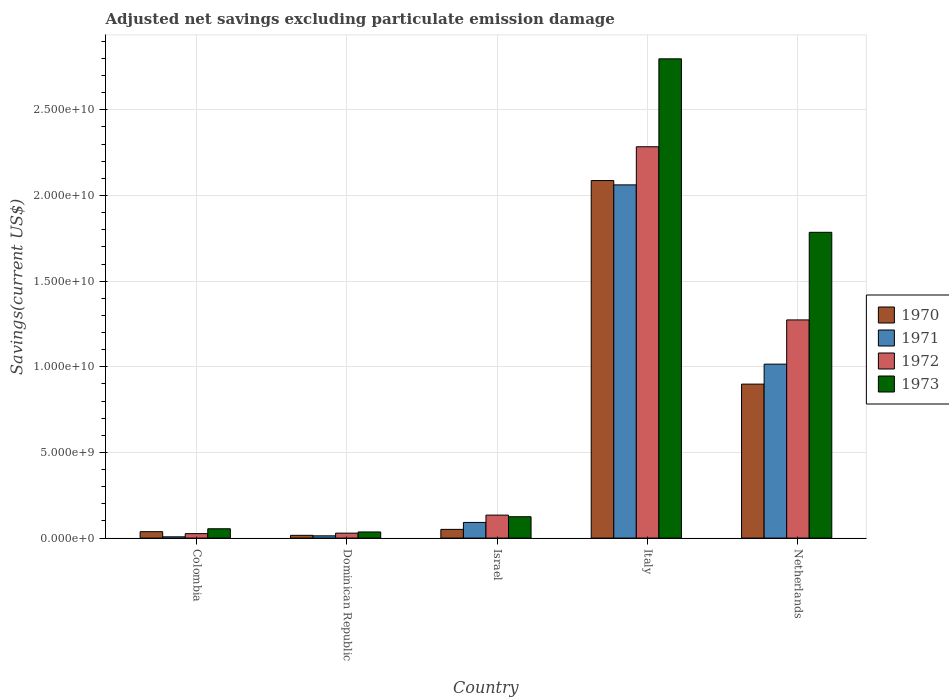Are the number of bars on each tick of the X-axis equal?
Make the answer very short. Yes. How many bars are there on the 1st tick from the left?
Your answer should be very brief. 4. In how many cases, is the number of bars for a given country not equal to the number of legend labels?
Offer a very short reply. 0. What is the adjusted net savings in 1971 in Colombia?
Your response must be concise. 7.46e+07. Across all countries, what is the maximum adjusted net savings in 1972?
Give a very brief answer. 2.28e+1. Across all countries, what is the minimum adjusted net savings in 1971?
Your answer should be very brief. 7.46e+07. In which country was the adjusted net savings in 1973 minimum?
Give a very brief answer. Dominican Republic. What is the total adjusted net savings in 1972 in the graph?
Offer a very short reply. 3.75e+1. What is the difference between the adjusted net savings in 1971 in Colombia and that in Netherlands?
Your response must be concise. -1.01e+1. What is the difference between the adjusted net savings in 1970 in Colombia and the adjusted net savings in 1973 in Netherlands?
Give a very brief answer. -1.75e+1. What is the average adjusted net savings in 1972 per country?
Your response must be concise. 7.49e+09. What is the difference between the adjusted net savings of/in 1972 and adjusted net savings of/in 1971 in Israel?
Offer a terse response. 4.27e+08. What is the ratio of the adjusted net savings in 1973 in Colombia to that in Italy?
Make the answer very short. 0.02. What is the difference between the highest and the second highest adjusted net savings in 1972?
Give a very brief answer. -2.15e+1. What is the difference between the highest and the lowest adjusted net savings in 1972?
Your answer should be compact. 2.26e+1. Is the sum of the adjusted net savings in 1973 in Dominican Republic and Netherlands greater than the maximum adjusted net savings in 1972 across all countries?
Your response must be concise. No. Are all the bars in the graph horizontal?
Keep it short and to the point. No. Are the values on the major ticks of Y-axis written in scientific E-notation?
Your answer should be compact. Yes. Where does the legend appear in the graph?
Keep it short and to the point. Center right. How many legend labels are there?
Give a very brief answer. 4. How are the legend labels stacked?
Your answer should be compact. Vertical. What is the title of the graph?
Offer a very short reply. Adjusted net savings excluding particulate emission damage. Does "1967" appear as one of the legend labels in the graph?
Your response must be concise. No. What is the label or title of the X-axis?
Make the answer very short. Country. What is the label or title of the Y-axis?
Your response must be concise. Savings(current US$). What is the Savings(current US$) of 1970 in Colombia?
Ensure brevity in your answer.  3.74e+08. What is the Savings(current US$) of 1971 in Colombia?
Give a very brief answer. 7.46e+07. What is the Savings(current US$) of 1972 in Colombia?
Provide a short and direct response. 2.60e+08. What is the Savings(current US$) of 1973 in Colombia?
Give a very brief answer. 5.45e+08. What is the Savings(current US$) of 1970 in Dominican Republic?
Your answer should be very brief. 1.61e+08. What is the Savings(current US$) of 1971 in Dominican Republic?
Provide a short and direct response. 1.32e+08. What is the Savings(current US$) of 1972 in Dominican Republic?
Make the answer very short. 2.89e+08. What is the Savings(current US$) in 1973 in Dominican Republic?
Offer a terse response. 3.58e+08. What is the Savings(current US$) of 1970 in Israel?
Your answer should be compact. 5.08e+08. What is the Savings(current US$) in 1971 in Israel?
Provide a succinct answer. 9.14e+08. What is the Savings(current US$) in 1972 in Israel?
Make the answer very short. 1.34e+09. What is the Savings(current US$) in 1973 in Israel?
Your answer should be compact. 1.25e+09. What is the Savings(current US$) in 1970 in Italy?
Ensure brevity in your answer.  2.09e+1. What is the Savings(current US$) of 1971 in Italy?
Your response must be concise. 2.06e+1. What is the Savings(current US$) of 1972 in Italy?
Provide a succinct answer. 2.28e+1. What is the Savings(current US$) in 1973 in Italy?
Your answer should be compact. 2.80e+1. What is the Savings(current US$) of 1970 in Netherlands?
Provide a short and direct response. 8.99e+09. What is the Savings(current US$) in 1971 in Netherlands?
Ensure brevity in your answer.  1.02e+1. What is the Savings(current US$) of 1972 in Netherlands?
Provide a succinct answer. 1.27e+1. What is the Savings(current US$) in 1973 in Netherlands?
Offer a terse response. 1.79e+1. Across all countries, what is the maximum Savings(current US$) of 1970?
Give a very brief answer. 2.09e+1. Across all countries, what is the maximum Savings(current US$) in 1971?
Offer a terse response. 2.06e+1. Across all countries, what is the maximum Savings(current US$) in 1972?
Ensure brevity in your answer.  2.28e+1. Across all countries, what is the maximum Savings(current US$) in 1973?
Offer a terse response. 2.80e+1. Across all countries, what is the minimum Savings(current US$) in 1970?
Offer a terse response. 1.61e+08. Across all countries, what is the minimum Savings(current US$) of 1971?
Your answer should be compact. 7.46e+07. Across all countries, what is the minimum Savings(current US$) of 1972?
Ensure brevity in your answer.  2.60e+08. Across all countries, what is the minimum Savings(current US$) of 1973?
Make the answer very short. 3.58e+08. What is the total Savings(current US$) of 1970 in the graph?
Ensure brevity in your answer.  3.09e+1. What is the total Savings(current US$) of 1971 in the graph?
Your response must be concise. 3.19e+1. What is the total Savings(current US$) in 1972 in the graph?
Keep it short and to the point. 3.75e+1. What is the total Savings(current US$) in 1973 in the graph?
Provide a short and direct response. 4.80e+1. What is the difference between the Savings(current US$) of 1970 in Colombia and that in Dominican Republic?
Offer a very short reply. 2.13e+08. What is the difference between the Savings(current US$) in 1971 in Colombia and that in Dominican Republic?
Your answer should be compact. -5.69e+07. What is the difference between the Savings(current US$) of 1972 in Colombia and that in Dominican Republic?
Offer a terse response. -2.84e+07. What is the difference between the Savings(current US$) in 1973 in Colombia and that in Dominican Republic?
Your answer should be compact. 1.87e+08. What is the difference between the Savings(current US$) in 1970 in Colombia and that in Israel?
Offer a terse response. -1.34e+08. What is the difference between the Savings(current US$) in 1971 in Colombia and that in Israel?
Give a very brief answer. -8.40e+08. What is the difference between the Savings(current US$) in 1972 in Colombia and that in Israel?
Your answer should be very brief. -1.08e+09. What is the difference between the Savings(current US$) of 1973 in Colombia and that in Israel?
Make the answer very short. -7.02e+08. What is the difference between the Savings(current US$) of 1970 in Colombia and that in Italy?
Your answer should be very brief. -2.05e+1. What is the difference between the Savings(current US$) in 1971 in Colombia and that in Italy?
Give a very brief answer. -2.05e+1. What is the difference between the Savings(current US$) in 1972 in Colombia and that in Italy?
Offer a terse response. -2.26e+1. What is the difference between the Savings(current US$) in 1973 in Colombia and that in Italy?
Your answer should be compact. -2.74e+1. What is the difference between the Savings(current US$) of 1970 in Colombia and that in Netherlands?
Provide a succinct answer. -8.61e+09. What is the difference between the Savings(current US$) in 1971 in Colombia and that in Netherlands?
Your answer should be very brief. -1.01e+1. What is the difference between the Savings(current US$) of 1972 in Colombia and that in Netherlands?
Give a very brief answer. -1.25e+1. What is the difference between the Savings(current US$) in 1973 in Colombia and that in Netherlands?
Keep it short and to the point. -1.73e+1. What is the difference between the Savings(current US$) in 1970 in Dominican Republic and that in Israel?
Your response must be concise. -3.47e+08. What is the difference between the Savings(current US$) in 1971 in Dominican Republic and that in Israel?
Your answer should be very brief. -7.83e+08. What is the difference between the Savings(current US$) of 1972 in Dominican Republic and that in Israel?
Give a very brief answer. -1.05e+09. What is the difference between the Savings(current US$) in 1973 in Dominican Republic and that in Israel?
Offer a terse response. -8.89e+08. What is the difference between the Savings(current US$) of 1970 in Dominican Republic and that in Italy?
Ensure brevity in your answer.  -2.07e+1. What is the difference between the Savings(current US$) in 1971 in Dominican Republic and that in Italy?
Make the answer very short. -2.05e+1. What is the difference between the Savings(current US$) in 1972 in Dominican Republic and that in Italy?
Make the answer very short. -2.26e+1. What is the difference between the Savings(current US$) in 1973 in Dominican Republic and that in Italy?
Your answer should be very brief. -2.76e+1. What is the difference between the Savings(current US$) of 1970 in Dominican Republic and that in Netherlands?
Ensure brevity in your answer.  -8.83e+09. What is the difference between the Savings(current US$) in 1971 in Dominican Republic and that in Netherlands?
Provide a succinct answer. -1.00e+1. What is the difference between the Savings(current US$) in 1972 in Dominican Republic and that in Netherlands?
Provide a short and direct response. -1.24e+1. What is the difference between the Savings(current US$) of 1973 in Dominican Republic and that in Netherlands?
Provide a succinct answer. -1.75e+1. What is the difference between the Savings(current US$) of 1970 in Israel and that in Italy?
Give a very brief answer. -2.04e+1. What is the difference between the Savings(current US$) of 1971 in Israel and that in Italy?
Your answer should be very brief. -1.97e+1. What is the difference between the Savings(current US$) of 1972 in Israel and that in Italy?
Provide a short and direct response. -2.15e+1. What is the difference between the Savings(current US$) in 1973 in Israel and that in Italy?
Your answer should be very brief. -2.67e+1. What is the difference between the Savings(current US$) in 1970 in Israel and that in Netherlands?
Make the answer very short. -8.48e+09. What is the difference between the Savings(current US$) in 1971 in Israel and that in Netherlands?
Make the answer very short. -9.24e+09. What is the difference between the Savings(current US$) in 1972 in Israel and that in Netherlands?
Provide a short and direct response. -1.14e+1. What is the difference between the Savings(current US$) of 1973 in Israel and that in Netherlands?
Make the answer very short. -1.66e+1. What is the difference between the Savings(current US$) in 1970 in Italy and that in Netherlands?
Your answer should be compact. 1.19e+1. What is the difference between the Savings(current US$) in 1971 in Italy and that in Netherlands?
Your answer should be very brief. 1.05e+1. What is the difference between the Savings(current US$) in 1972 in Italy and that in Netherlands?
Provide a short and direct response. 1.01e+1. What is the difference between the Savings(current US$) in 1973 in Italy and that in Netherlands?
Make the answer very short. 1.01e+1. What is the difference between the Savings(current US$) of 1970 in Colombia and the Savings(current US$) of 1971 in Dominican Republic?
Your answer should be compact. 2.42e+08. What is the difference between the Savings(current US$) of 1970 in Colombia and the Savings(current US$) of 1972 in Dominican Republic?
Offer a very short reply. 8.52e+07. What is the difference between the Savings(current US$) of 1970 in Colombia and the Savings(current US$) of 1973 in Dominican Republic?
Provide a short and direct response. 1.57e+07. What is the difference between the Savings(current US$) in 1971 in Colombia and the Savings(current US$) in 1972 in Dominican Republic?
Your answer should be very brief. -2.14e+08. What is the difference between the Savings(current US$) in 1971 in Colombia and the Savings(current US$) in 1973 in Dominican Republic?
Your answer should be very brief. -2.84e+08. What is the difference between the Savings(current US$) of 1972 in Colombia and the Savings(current US$) of 1973 in Dominican Republic?
Ensure brevity in your answer.  -9.79e+07. What is the difference between the Savings(current US$) in 1970 in Colombia and the Savings(current US$) in 1971 in Israel?
Provide a succinct answer. -5.40e+08. What is the difference between the Savings(current US$) of 1970 in Colombia and the Savings(current US$) of 1972 in Israel?
Make the answer very short. -9.67e+08. What is the difference between the Savings(current US$) of 1970 in Colombia and the Savings(current US$) of 1973 in Israel?
Offer a terse response. -8.73e+08. What is the difference between the Savings(current US$) in 1971 in Colombia and the Savings(current US$) in 1972 in Israel?
Provide a succinct answer. -1.27e+09. What is the difference between the Savings(current US$) in 1971 in Colombia and the Savings(current US$) in 1973 in Israel?
Keep it short and to the point. -1.17e+09. What is the difference between the Savings(current US$) in 1972 in Colombia and the Savings(current US$) in 1973 in Israel?
Ensure brevity in your answer.  -9.87e+08. What is the difference between the Savings(current US$) in 1970 in Colombia and the Savings(current US$) in 1971 in Italy?
Your response must be concise. -2.02e+1. What is the difference between the Savings(current US$) of 1970 in Colombia and the Savings(current US$) of 1972 in Italy?
Make the answer very short. -2.25e+1. What is the difference between the Savings(current US$) in 1970 in Colombia and the Savings(current US$) in 1973 in Italy?
Make the answer very short. -2.76e+1. What is the difference between the Savings(current US$) in 1971 in Colombia and the Savings(current US$) in 1972 in Italy?
Ensure brevity in your answer.  -2.28e+1. What is the difference between the Savings(current US$) in 1971 in Colombia and the Savings(current US$) in 1973 in Italy?
Ensure brevity in your answer.  -2.79e+1. What is the difference between the Savings(current US$) in 1972 in Colombia and the Savings(current US$) in 1973 in Italy?
Provide a succinct answer. -2.77e+1. What is the difference between the Savings(current US$) of 1970 in Colombia and the Savings(current US$) of 1971 in Netherlands?
Give a very brief answer. -9.78e+09. What is the difference between the Savings(current US$) in 1970 in Colombia and the Savings(current US$) in 1972 in Netherlands?
Your answer should be very brief. -1.24e+1. What is the difference between the Savings(current US$) of 1970 in Colombia and the Savings(current US$) of 1973 in Netherlands?
Offer a very short reply. -1.75e+1. What is the difference between the Savings(current US$) in 1971 in Colombia and the Savings(current US$) in 1972 in Netherlands?
Offer a terse response. -1.27e+1. What is the difference between the Savings(current US$) of 1971 in Colombia and the Savings(current US$) of 1973 in Netherlands?
Your answer should be very brief. -1.78e+1. What is the difference between the Savings(current US$) in 1972 in Colombia and the Savings(current US$) in 1973 in Netherlands?
Your answer should be compact. -1.76e+1. What is the difference between the Savings(current US$) in 1970 in Dominican Republic and the Savings(current US$) in 1971 in Israel?
Keep it short and to the point. -7.53e+08. What is the difference between the Savings(current US$) in 1970 in Dominican Republic and the Savings(current US$) in 1972 in Israel?
Offer a very short reply. -1.18e+09. What is the difference between the Savings(current US$) in 1970 in Dominican Republic and the Savings(current US$) in 1973 in Israel?
Offer a terse response. -1.09e+09. What is the difference between the Savings(current US$) in 1971 in Dominican Republic and the Savings(current US$) in 1972 in Israel?
Provide a succinct answer. -1.21e+09. What is the difference between the Savings(current US$) in 1971 in Dominican Republic and the Savings(current US$) in 1973 in Israel?
Your answer should be very brief. -1.12e+09. What is the difference between the Savings(current US$) in 1972 in Dominican Republic and the Savings(current US$) in 1973 in Israel?
Offer a terse response. -9.58e+08. What is the difference between the Savings(current US$) in 1970 in Dominican Republic and the Savings(current US$) in 1971 in Italy?
Make the answer very short. -2.05e+1. What is the difference between the Savings(current US$) of 1970 in Dominican Republic and the Savings(current US$) of 1972 in Italy?
Keep it short and to the point. -2.27e+1. What is the difference between the Savings(current US$) in 1970 in Dominican Republic and the Savings(current US$) in 1973 in Italy?
Offer a terse response. -2.78e+1. What is the difference between the Savings(current US$) in 1971 in Dominican Republic and the Savings(current US$) in 1972 in Italy?
Give a very brief answer. -2.27e+1. What is the difference between the Savings(current US$) of 1971 in Dominican Republic and the Savings(current US$) of 1973 in Italy?
Provide a short and direct response. -2.78e+1. What is the difference between the Savings(current US$) of 1972 in Dominican Republic and the Savings(current US$) of 1973 in Italy?
Your response must be concise. -2.77e+1. What is the difference between the Savings(current US$) in 1970 in Dominican Republic and the Savings(current US$) in 1971 in Netherlands?
Your answer should be compact. -9.99e+09. What is the difference between the Savings(current US$) of 1970 in Dominican Republic and the Savings(current US$) of 1972 in Netherlands?
Your answer should be very brief. -1.26e+1. What is the difference between the Savings(current US$) in 1970 in Dominican Republic and the Savings(current US$) in 1973 in Netherlands?
Offer a terse response. -1.77e+1. What is the difference between the Savings(current US$) of 1971 in Dominican Republic and the Savings(current US$) of 1972 in Netherlands?
Your response must be concise. -1.26e+1. What is the difference between the Savings(current US$) in 1971 in Dominican Republic and the Savings(current US$) in 1973 in Netherlands?
Provide a short and direct response. -1.77e+1. What is the difference between the Savings(current US$) of 1972 in Dominican Republic and the Savings(current US$) of 1973 in Netherlands?
Ensure brevity in your answer.  -1.76e+1. What is the difference between the Savings(current US$) in 1970 in Israel and the Savings(current US$) in 1971 in Italy?
Ensure brevity in your answer.  -2.01e+1. What is the difference between the Savings(current US$) of 1970 in Israel and the Savings(current US$) of 1972 in Italy?
Give a very brief answer. -2.23e+1. What is the difference between the Savings(current US$) in 1970 in Israel and the Savings(current US$) in 1973 in Italy?
Your answer should be very brief. -2.75e+1. What is the difference between the Savings(current US$) of 1971 in Israel and the Savings(current US$) of 1972 in Italy?
Offer a very short reply. -2.19e+1. What is the difference between the Savings(current US$) of 1971 in Israel and the Savings(current US$) of 1973 in Italy?
Make the answer very short. -2.71e+1. What is the difference between the Savings(current US$) in 1972 in Israel and the Savings(current US$) in 1973 in Italy?
Your response must be concise. -2.66e+1. What is the difference between the Savings(current US$) of 1970 in Israel and the Savings(current US$) of 1971 in Netherlands?
Your response must be concise. -9.65e+09. What is the difference between the Savings(current US$) in 1970 in Israel and the Savings(current US$) in 1972 in Netherlands?
Keep it short and to the point. -1.22e+1. What is the difference between the Savings(current US$) in 1970 in Israel and the Savings(current US$) in 1973 in Netherlands?
Keep it short and to the point. -1.73e+1. What is the difference between the Savings(current US$) in 1971 in Israel and the Savings(current US$) in 1972 in Netherlands?
Give a very brief answer. -1.18e+1. What is the difference between the Savings(current US$) of 1971 in Israel and the Savings(current US$) of 1973 in Netherlands?
Make the answer very short. -1.69e+1. What is the difference between the Savings(current US$) of 1972 in Israel and the Savings(current US$) of 1973 in Netherlands?
Your answer should be compact. -1.65e+1. What is the difference between the Savings(current US$) in 1970 in Italy and the Savings(current US$) in 1971 in Netherlands?
Your answer should be very brief. 1.07e+1. What is the difference between the Savings(current US$) in 1970 in Italy and the Savings(current US$) in 1972 in Netherlands?
Offer a terse response. 8.14e+09. What is the difference between the Savings(current US$) of 1970 in Italy and the Savings(current US$) of 1973 in Netherlands?
Provide a succinct answer. 3.02e+09. What is the difference between the Savings(current US$) of 1971 in Italy and the Savings(current US$) of 1972 in Netherlands?
Ensure brevity in your answer.  7.88e+09. What is the difference between the Savings(current US$) in 1971 in Italy and the Savings(current US$) in 1973 in Netherlands?
Make the answer very short. 2.77e+09. What is the difference between the Savings(current US$) of 1972 in Italy and the Savings(current US$) of 1973 in Netherlands?
Your answer should be very brief. 4.99e+09. What is the average Savings(current US$) in 1970 per country?
Give a very brief answer. 6.18e+09. What is the average Savings(current US$) in 1971 per country?
Provide a succinct answer. 6.38e+09. What is the average Savings(current US$) in 1972 per country?
Ensure brevity in your answer.  7.49e+09. What is the average Savings(current US$) in 1973 per country?
Your response must be concise. 9.60e+09. What is the difference between the Savings(current US$) in 1970 and Savings(current US$) in 1971 in Colombia?
Provide a short and direct response. 2.99e+08. What is the difference between the Savings(current US$) in 1970 and Savings(current US$) in 1972 in Colombia?
Keep it short and to the point. 1.14e+08. What is the difference between the Savings(current US$) in 1970 and Savings(current US$) in 1973 in Colombia?
Make the answer very short. -1.71e+08. What is the difference between the Savings(current US$) in 1971 and Savings(current US$) in 1972 in Colombia?
Give a very brief answer. -1.86e+08. What is the difference between the Savings(current US$) in 1971 and Savings(current US$) in 1973 in Colombia?
Give a very brief answer. -4.70e+08. What is the difference between the Savings(current US$) in 1972 and Savings(current US$) in 1973 in Colombia?
Give a very brief answer. -2.85e+08. What is the difference between the Savings(current US$) in 1970 and Savings(current US$) in 1971 in Dominican Republic?
Offer a terse response. 2.96e+07. What is the difference between the Savings(current US$) of 1970 and Savings(current US$) of 1972 in Dominican Republic?
Provide a succinct answer. -1.28e+08. What is the difference between the Savings(current US$) in 1970 and Savings(current US$) in 1973 in Dominican Republic?
Provide a succinct answer. -1.97e+08. What is the difference between the Savings(current US$) of 1971 and Savings(current US$) of 1972 in Dominican Republic?
Offer a very short reply. -1.57e+08. What is the difference between the Savings(current US$) in 1971 and Savings(current US$) in 1973 in Dominican Republic?
Offer a very short reply. -2.27e+08. What is the difference between the Savings(current US$) in 1972 and Savings(current US$) in 1973 in Dominican Republic?
Make the answer very short. -6.95e+07. What is the difference between the Savings(current US$) in 1970 and Savings(current US$) in 1971 in Israel?
Keep it short and to the point. -4.06e+08. What is the difference between the Savings(current US$) of 1970 and Savings(current US$) of 1972 in Israel?
Keep it short and to the point. -8.33e+08. What is the difference between the Savings(current US$) of 1970 and Savings(current US$) of 1973 in Israel?
Offer a terse response. -7.39e+08. What is the difference between the Savings(current US$) of 1971 and Savings(current US$) of 1972 in Israel?
Ensure brevity in your answer.  -4.27e+08. What is the difference between the Savings(current US$) in 1971 and Savings(current US$) in 1973 in Israel?
Offer a terse response. -3.33e+08. What is the difference between the Savings(current US$) of 1972 and Savings(current US$) of 1973 in Israel?
Your response must be concise. 9.40e+07. What is the difference between the Savings(current US$) in 1970 and Savings(current US$) in 1971 in Italy?
Ensure brevity in your answer.  2.53e+08. What is the difference between the Savings(current US$) of 1970 and Savings(current US$) of 1972 in Italy?
Provide a short and direct response. -1.97e+09. What is the difference between the Savings(current US$) in 1970 and Savings(current US$) in 1973 in Italy?
Offer a very short reply. -7.11e+09. What is the difference between the Savings(current US$) of 1971 and Savings(current US$) of 1972 in Italy?
Provide a succinct answer. -2.23e+09. What is the difference between the Savings(current US$) in 1971 and Savings(current US$) in 1973 in Italy?
Your response must be concise. -7.36e+09. What is the difference between the Savings(current US$) of 1972 and Savings(current US$) of 1973 in Italy?
Keep it short and to the point. -5.13e+09. What is the difference between the Savings(current US$) of 1970 and Savings(current US$) of 1971 in Netherlands?
Provide a succinct answer. -1.17e+09. What is the difference between the Savings(current US$) of 1970 and Savings(current US$) of 1972 in Netherlands?
Your answer should be very brief. -3.75e+09. What is the difference between the Savings(current US$) in 1970 and Savings(current US$) in 1973 in Netherlands?
Your response must be concise. -8.86e+09. What is the difference between the Savings(current US$) of 1971 and Savings(current US$) of 1972 in Netherlands?
Make the answer very short. -2.58e+09. What is the difference between the Savings(current US$) of 1971 and Savings(current US$) of 1973 in Netherlands?
Keep it short and to the point. -7.70e+09. What is the difference between the Savings(current US$) in 1972 and Savings(current US$) in 1973 in Netherlands?
Ensure brevity in your answer.  -5.11e+09. What is the ratio of the Savings(current US$) in 1970 in Colombia to that in Dominican Republic?
Provide a short and direct response. 2.32. What is the ratio of the Savings(current US$) in 1971 in Colombia to that in Dominican Republic?
Ensure brevity in your answer.  0.57. What is the ratio of the Savings(current US$) of 1972 in Colombia to that in Dominican Republic?
Offer a terse response. 0.9. What is the ratio of the Savings(current US$) of 1973 in Colombia to that in Dominican Republic?
Your answer should be compact. 1.52. What is the ratio of the Savings(current US$) of 1970 in Colombia to that in Israel?
Ensure brevity in your answer.  0.74. What is the ratio of the Savings(current US$) of 1971 in Colombia to that in Israel?
Give a very brief answer. 0.08. What is the ratio of the Savings(current US$) in 1972 in Colombia to that in Israel?
Your answer should be compact. 0.19. What is the ratio of the Savings(current US$) in 1973 in Colombia to that in Israel?
Make the answer very short. 0.44. What is the ratio of the Savings(current US$) in 1970 in Colombia to that in Italy?
Provide a short and direct response. 0.02. What is the ratio of the Savings(current US$) in 1971 in Colombia to that in Italy?
Your response must be concise. 0. What is the ratio of the Savings(current US$) of 1972 in Colombia to that in Italy?
Your answer should be very brief. 0.01. What is the ratio of the Savings(current US$) in 1973 in Colombia to that in Italy?
Keep it short and to the point. 0.02. What is the ratio of the Savings(current US$) in 1970 in Colombia to that in Netherlands?
Give a very brief answer. 0.04. What is the ratio of the Savings(current US$) in 1971 in Colombia to that in Netherlands?
Your response must be concise. 0.01. What is the ratio of the Savings(current US$) in 1972 in Colombia to that in Netherlands?
Offer a terse response. 0.02. What is the ratio of the Savings(current US$) in 1973 in Colombia to that in Netherlands?
Offer a very short reply. 0.03. What is the ratio of the Savings(current US$) in 1970 in Dominican Republic to that in Israel?
Your answer should be compact. 0.32. What is the ratio of the Savings(current US$) of 1971 in Dominican Republic to that in Israel?
Provide a succinct answer. 0.14. What is the ratio of the Savings(current US$) of 1972 in Dominican Republic to that in Israel?
Keep it short and to the point. 0.22. What is the ratio of the Savings(current US$) of 1973 in Dominican Republic to that in Israel?
Provide a short and direct response. 0.29. What is the ratio of the Savings(current US$) in 1970 in Dominican Republic to that in Italy?
Provide a succinct answer. 0.01. What is the ratio of the Savings(current US$) in 1971 in Dominican Republic to that in Italy?
Ensure brevity in your answer.  0.01. What is the ratio of the Savings(current US$) of 1972 in Dominican Republic to that in Italy?
Make the answer very short. 0.01. What is the ratio of the Savings(current US$) of 1973 in Dominican Republic to that in Italy?
Your answer should be compact. 0.01. What is the ratio of the Savings(current US$) of 1970 in Dominican Republic to that in Netherlands?
Your answer should be compact. 0.02. What is the ratio of the Savings(current US$) in 1971 in Dominican Republic to that in Netherlands?
Your answer should be compact. 0.01. What is the ratio of the Savings(current US$) of 1972 in Dominican Republic to that in Netherlands?
Your answer should be compact. 0.02. What is the ratio of the Savings(current US$) of 1973 in Dominican Republic to that in Netherlands?
Give a very brief answer. 0.02. What is the ratio of the Savings(current US$) of 1970 in Israel to that in Italy?
Keep it short and to the point. 0.02. What is the ratio of the Savings(current US$) in 1971 in Israel to that in Italy?
Your response must be concise. 0.04. What is the ratio of the Savings(current US$) of 1972 in Israel to that in Italy?
Your answer should be compact. 0.06. What is the ratio of the Savings(current US$) of 1973 in Israel to that in Italy?
Offer a terse response. 0.04. What is the ratio of the Savings(current US$) in 1970 in Israel to that in Netherlands?
Offer a very short reply. 0.06. What is the ratio of the Savings(current US$) of 1971 in Israel to that in Netherlands?
Offer a very short reply. 0.09. What is the ratio of the Savings(current US$) in 1972 in Israel to that in Netherlands?
Your response must be concise. 0.11. What is the ratio of the Savings(current US$) in 1973 in Israel to that in Netherlands?
Your answer should be very brief. 0.07. What is the ratio of the Savings(current US$) in 1970 in Italy to that in Netherlands?
Provide a succinct answer. 2.32. What is the ratio of the Savings(current US$) in 1971 in Italy to that in Netherlands?
Your answer should be very brief. 2.03. What is the ratio of the Savings(current US$) in 1972 in Italy to that in Netherlands?
Make the answer very short. 1.79. What is the ratio of the Savings(current US$) of 1973 in Italy to that in Netherlands?
Offer a terse response. 1.57. What is the difference between the highest and the second highest Savings(current US$) in 1970?
Offer a terse response. 1.19e+1. What is the difference between the highest and the second highest Savings(current US$) of 1971?
Provide a short and direct response. 1.05e+1. What is the difference between the highest and the second highest Savings(current US$) of 1972?
Make the answer very short. 1.01e+1. What is the difference between the highest and the second highest Savings(current US$) of 1973?
Provide a short and direct response. 1.01e+1. What is the difference between the highest and the lowest Savings(current US$) in 1970?
Ensure brevity in your answer.  2.07e+1. What is the difference between the highest and the lowest Savings(current US$) in 1971?
Provide a short and direct response. 2.05e+1. What is the difference between the highest and the lowest Savings(current US$) in 1972?
Ensure brevity in your answer.  2.26e+1. What is the difference between the highest and the lowest Savings(current US$) in 1973?
Your response must be concise. 2.76e+1. 